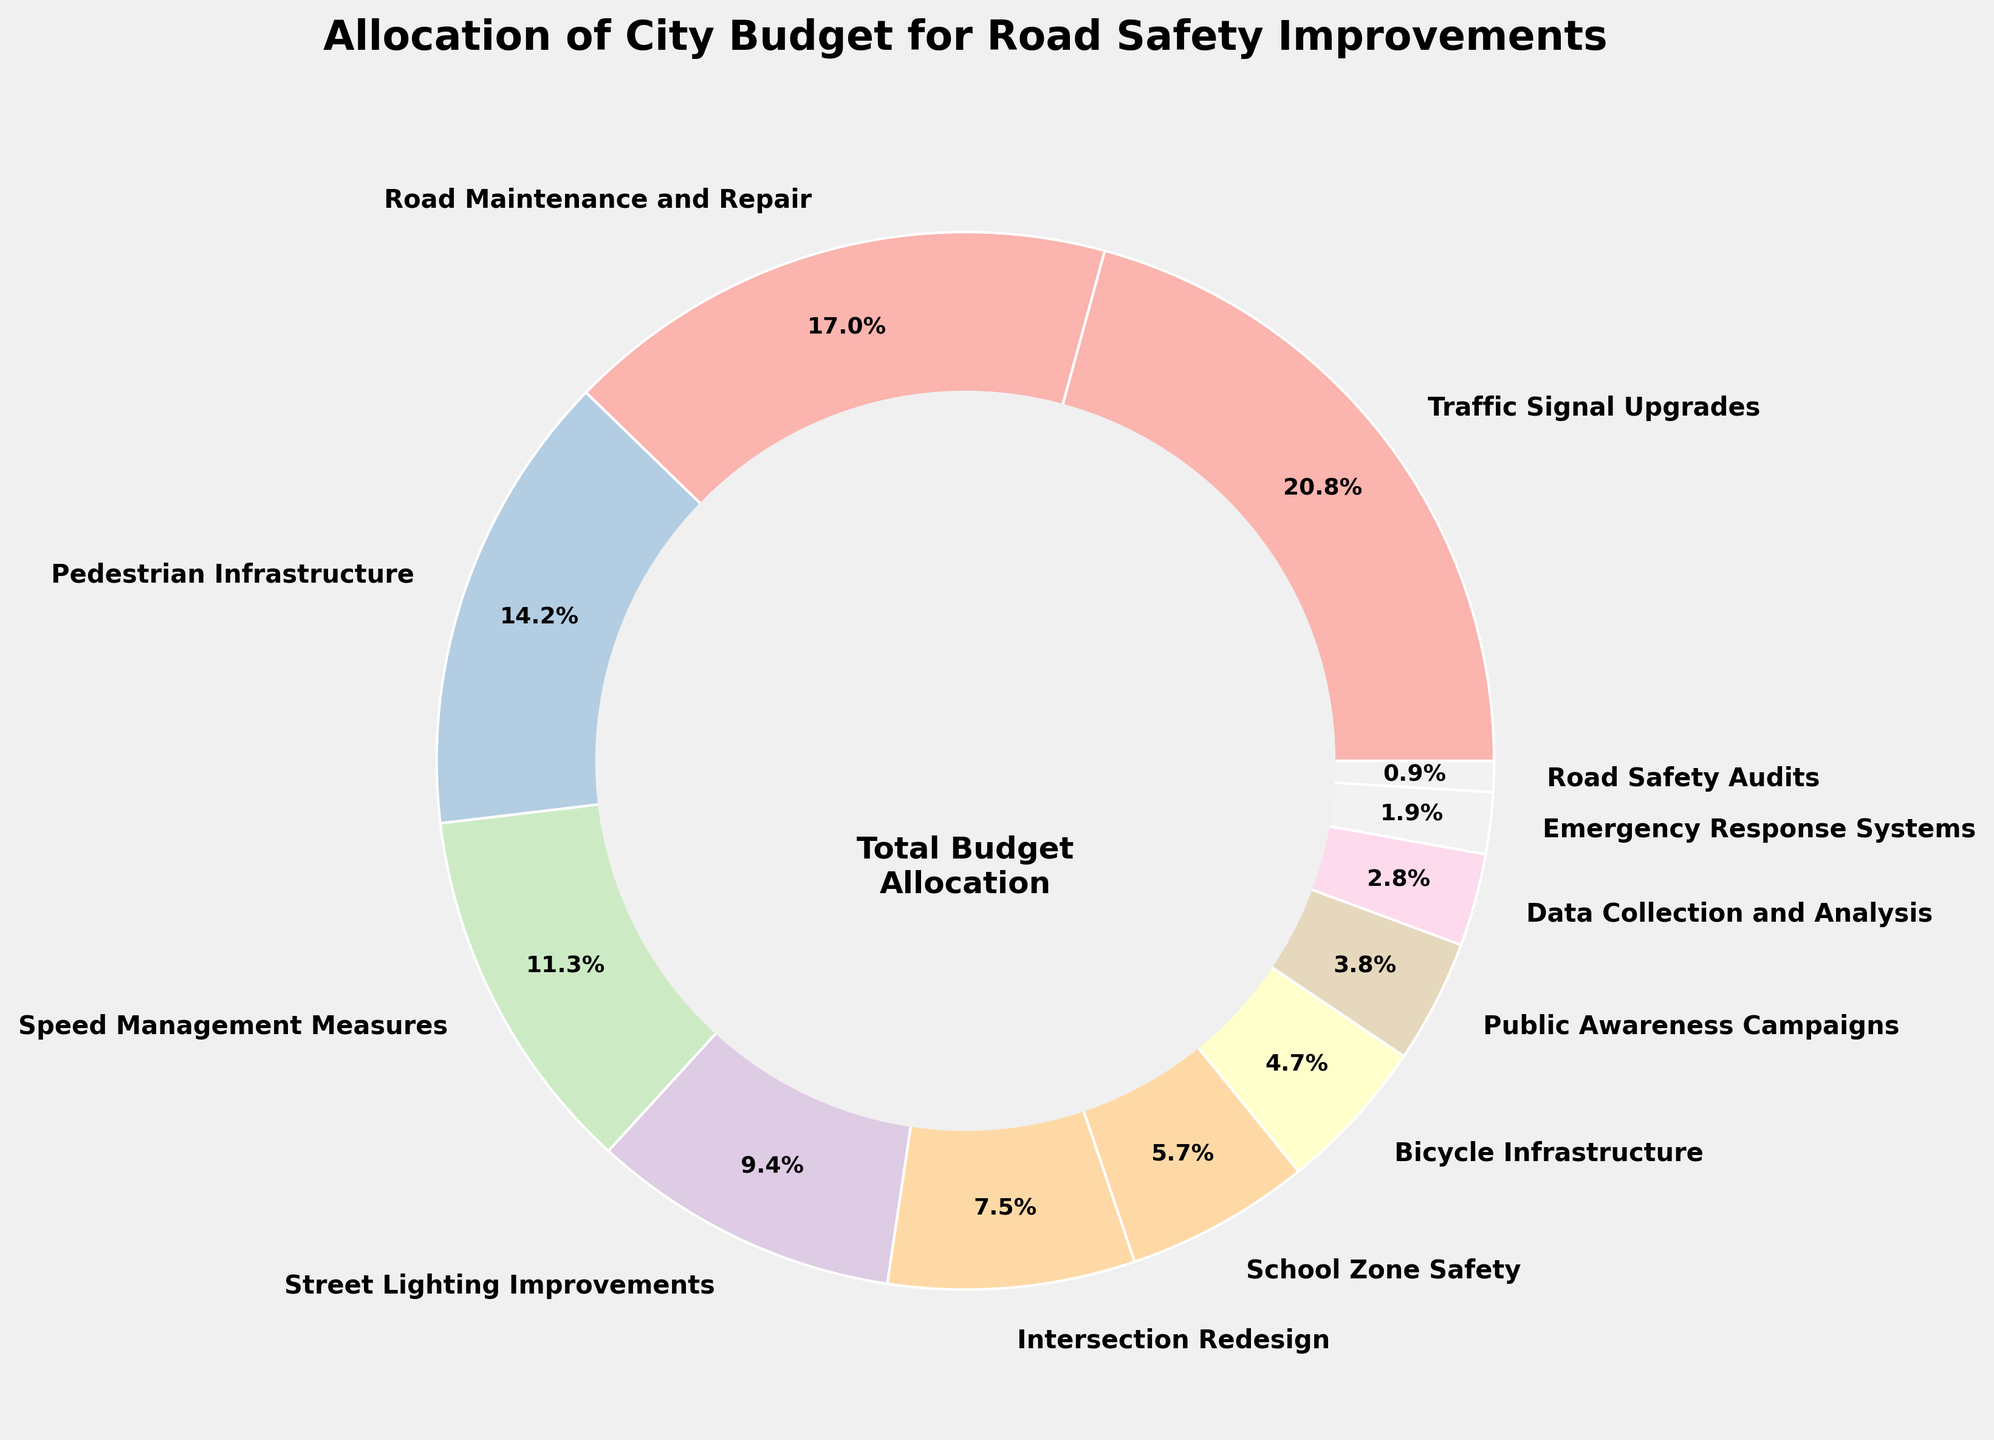What category represents the largest portion of the budget allocation? To determine the largest category, look at the percentages for each category on the pie chart. Traffic Signal Upgrades has the highest percentage at 22%.
Answer: Traffic Signal Upgrades What is the combined percentage allocated to Pedestrian Infrastructure and Bicycle Infrastructure? Add the percentages for Pedestrian Infrastructure (15%) and Bicycle Infrastructure (5%). The sum is 15% + 5% = 20%.
Answer: 20% Which category takes up more of the budget: Speed Management Measures or Street Lighting Improvements? Compare the percentages for Speed Management Measures (12%) and Street Lighting Improvements (10%). 12% is greater than 10%.
Answer: Speed Management Measures What is the total percentage of the budget allocated to Intersection Redesign, School Zone Safety, and Public Awareness Campaigns? Add the percentages for Intersection Redesign (8%), School Zone Safety (6%), and Public Awareness Campaigns (4%). The sum is 8% + 6% + 4% = 18%.
Answer: 18% Which two categories combined have the same percentage allocation as Road Maintenance and Repair? The percentage for Road Maintenance and Repair is 18%. Adding Street Lighting Improvements (10%) and School Zone Safety (6%) gives 10% + 6% = 16%, which is not correct. Adding Speed Management Measures (12%) and Bicycle Infrastructure (5%) gives 12% + 5% = 17%, which is also not correct. Adding Speed Management Measures (12%) and Data Collection and Analysis (3%) gives 12% + 3% = 15%, which is still incorrect. Adding Speed Management Measures (12%) and Pedestrian Infrastructure (15%) totals 27%, which is also incorrect. Adding Intersection Redesign (8%) and School Zone Safety (6%) totals 14%, which is also incorrect. Adding Street Lighting Improvements (10%) and Bicycle Infrastructure (5%) gives 15%, which is incorrect. Adding Intersection Redesign (8%) and Pedestrian Infrastructure (15%) totals 23%, which is greater. The correct combination is Street Lighting Improvements (10%) and Emergency Response Systems (2%) gives 10% + 2% = 12%.
Answer: No combination matches exactly 18% What is the difference in budget allocation between Traffic Signal Upgrades and Road Maintenance and Repair? Traffic Signal Upgrades has 22% and Road Maintenance and Repair has 18%. The difference is 22% - 18% = 4%.
Answer: 4% Which category has the lowest budget allocation? To find the category with the lowest allocation, look at the smallest percentage on the pie chart, which is 1% for Road Safety Audits.
Answer: Road Safety Audits What percentage of the budget is allocated to categories that directly improve pedestrian safety (include Pedestrian Infrastructure and School Zone Safety)? Add the percentages for Pedestrian Infrastructure (15%) and School Zone Safety (6%). The sum is 15% + 6% = 21%.
Answer: 21% 